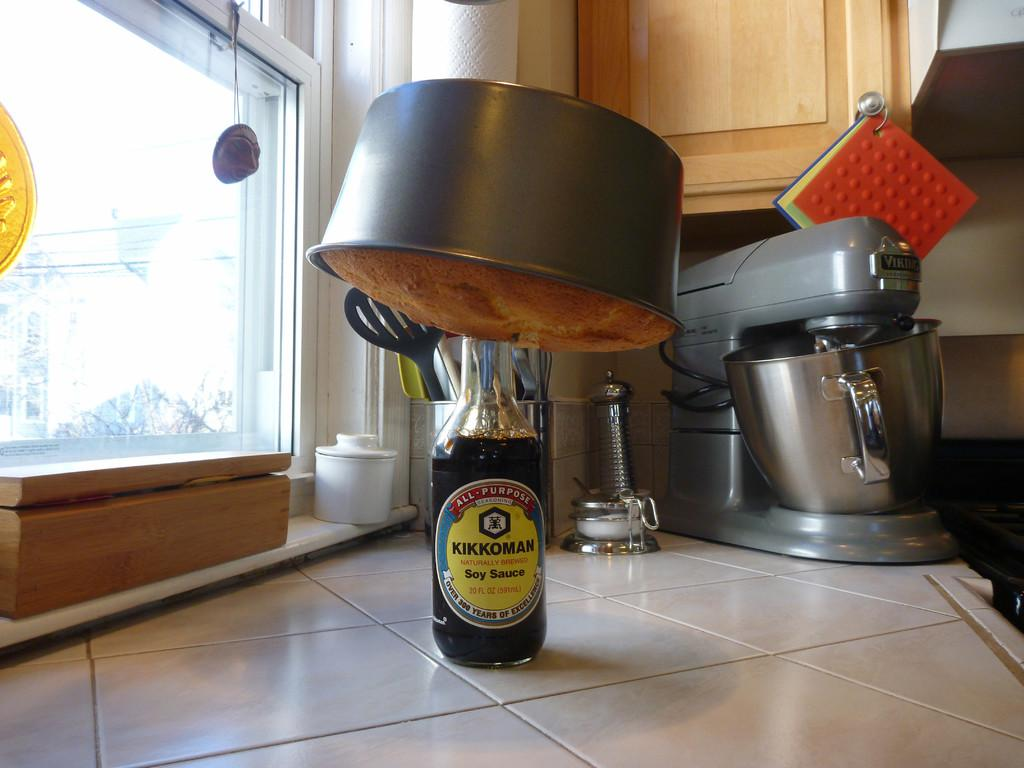<image>
Provide a brief description of the given image. A kikkoman soy sauce with a cake stuck in the top . 